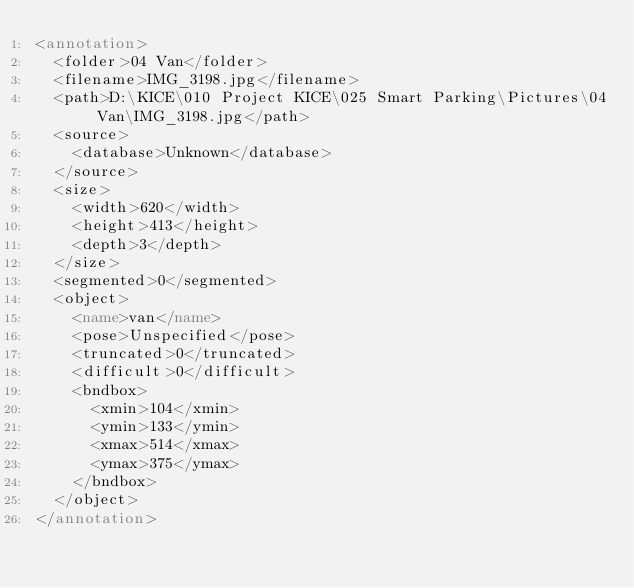Convert code to text. <code><loc_0><loc_0><loc_500><loc_500><_XML_><annotation>
	<folder>04 Van</folder>
	<filename>IMG_3198.jpg</filename>
	<path>D:\KICE\010 Project KICE\025 Smart Parking\Pictures\04 Van\IMG_3198.jpg</path>
	<source>
		<database>Unknown</database>
	</source>
	<size>
		<width>620</width>
		<height>413</height>
		<depth>3</depth>
	</size>
	<segmented>0</segmented>
	<object>
		<name>van</name>
		<pose>Unspecified</pose>
		<truncated>0</truncated>
		<difficult>0</difficult>
		<bndbox>
			<xmin>104</xmin>
			<ymin>133</ymin>
			<xmax>514</xmax>
			<ymax>375</ymax>
		</bndbox>
	</object>
</annotation>
</code> 